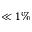Convert formula to latex. <formula><loc_0><loc_0><loc_500><loc_500>\ll 1 \%</formula> 